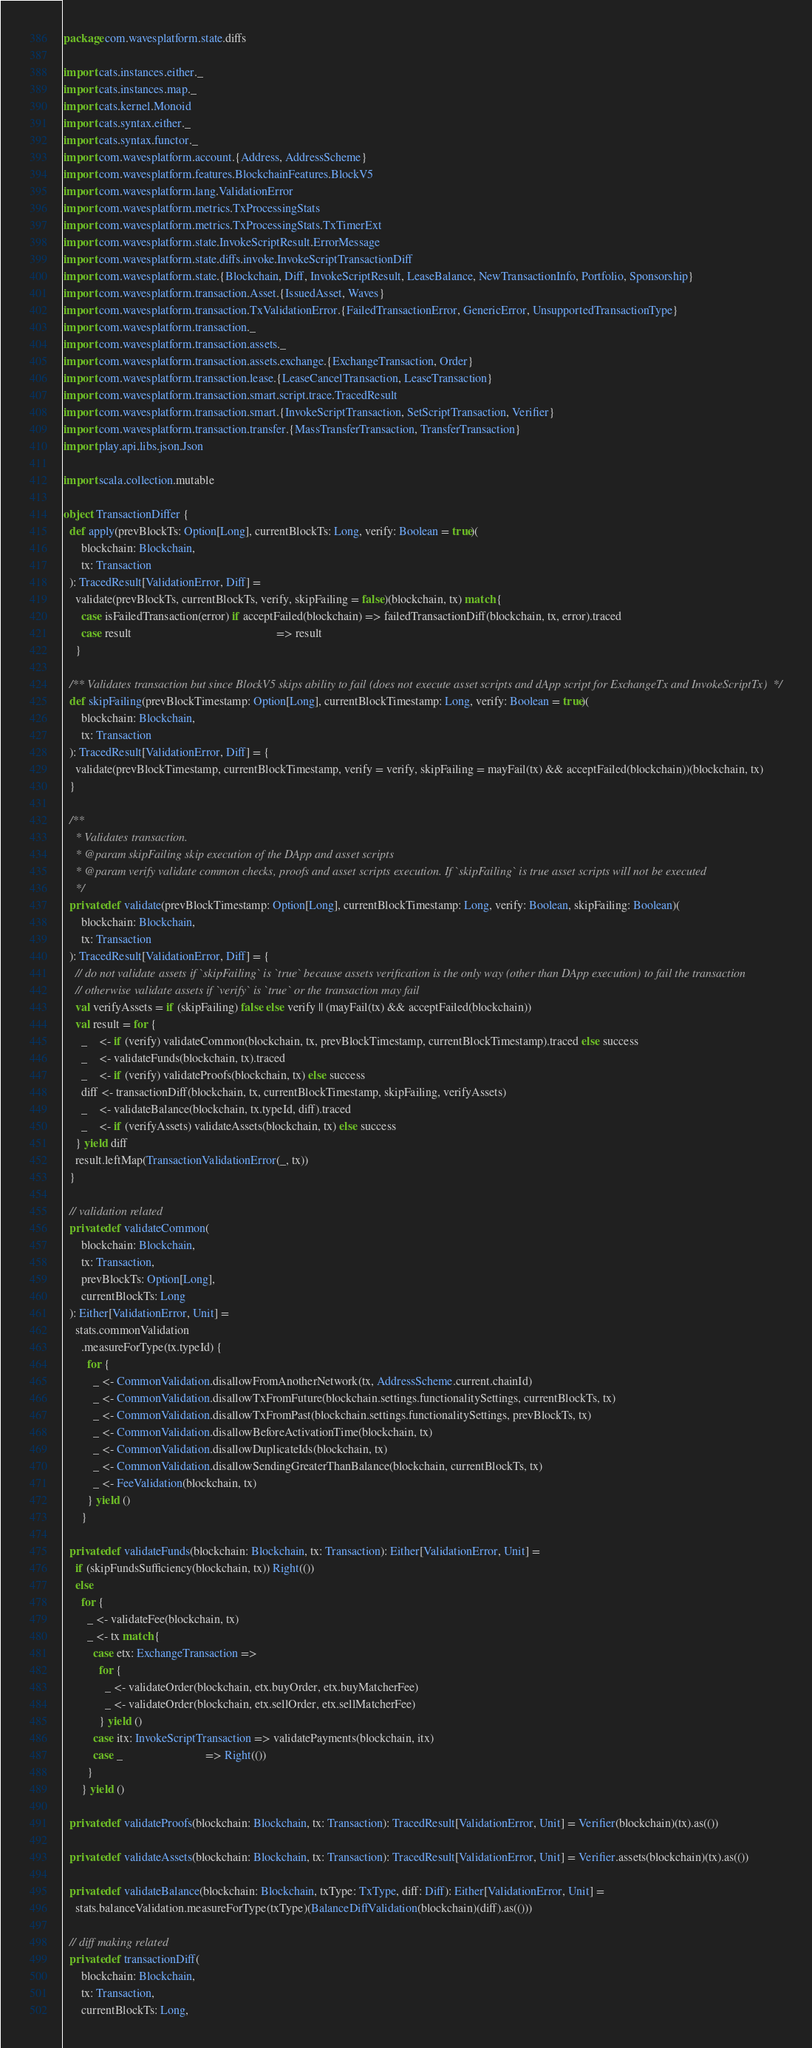<code> <loc_0><loc_0><loc_500><loc_500><_Scala_>package com.wavesplatform.state.diffs

import cats.instances.either._
import cats.instances.map._
import cats.kernel.Monoid
import cats.syntax.either._
import cats.syntax.functor._
import com.wavesplatform.account.{Address, AddressScheme}
import com.wavesplatform.features.BlockchainFeatures.BlockV5
import com.wavesplatform.lang.ValidationError
import com.wavesplatform.metrics.TxProcessingStats
import com.wavesplatform.metrics.TxProcessingStats.TxTimerExt
import com.wavesplatform.state.InvokeScriptResult.ErrorMessage
import com.wavesplatform.state.diffs.invoke.InvokeScriptTransactionDiff
import com.wavesplatform.state.{Blockchain, Diff, InvokeScriptResult, LeaseBalance, NewTransactionInfo, Portfolio, Sponsorship}
import com.wavesplatform.transaction.Asset.{IssuedAsset, Waves}
import com.wavesplatform.transaction.TxValidationError.{FailedTransactionError, GenericError, UnsupportedTransactionType}
import com.wavesplatform.transaction._
import com.wavesplatform.transaction.assets._
import com.wavesplatform.transaction.assets.exchange.{ExchangeTransaction, Order}
import com.wavesplatform.transaction.lease.{LeaseCancelTransaction, LeaseTransaction}
import com.wavesplatform.transaction.smart.script.trace.TracedResult
import com.wavesplatform.transaction.smart.{InvokeScriptTransaction, SetScriptTransaction, Verifier}
import com.wavesplatform.transaction.transfer.{MassTransferTransaction, TransferTransaction}
import play.api.libs.json.Json

import scala.collection.mutable

object TransactionDiffer {
  def apply(prevBlockTs: Option[Long], currentBlockTs: Long, verify: Boolean = true)(
      blockchain: Blockchain,
      tx: Transaction
  ): TracedResult[ValidationError, Diff] =
    validate(prevBlockTs, currentBlockTs, verify, skipFailing = false)(blockchain, tx) match {
      case isFailedTransaction(error) if acceptFailed(blockchain) => failedTransactionDiff(blockchain, tx, error).traced
      case result                                                 => result
    }

  /** Validates transaction but since BlockV5 skips ability to fail (does not execute asset scripts and dApp script for ExchangeTx and InvokeScriptTx) */
  def skipFailing(prevBlockTimestamp: Option[Long], currentBlockTimestamp: Long, verify: Boolean = true)(
      blockchain: Blockchain,
      tx: Transaction
  ): TracedResult[ValidationError, Diff] = {
    validate(prevBlockTimestamp, currentBlockTimestamp, verify = verify, skipFailing = mayFail(tx) && acceptFailed(blockchain))(blockchain, tx)
  }

  /**
    * Validates transaction.
    * @param skipFailing skip execution of the DApp and asset scripts
    * @param verify validate common checks, proofs and asset scripts execution. If `skipFailing` is true asset scripts will not be executed
    */
  private def validate(prevBlockTimestamp: Option[Long], currentBlockTimestamp: Long, verify: Boolean, skipFailing: Boolean)(
      blockchain: Blockchain,
      tx: Transaction
  ): TracedResult[ValidationError, Diff] = {
    // do not validate assets if `skipFailing` is `true` because assets verification is the only way (other than DApp execution) to fail the transaction
    // otherwise validate assets if `verify` is `true` or the transaction may fail
    val verifyAssets = if (skipFailing) false else verify || (mayFail(tx) && acceptFailed(blockchain))
    val result = for {
      _    <- if (verify) validateCommon(blockchain, tx, prevBlockTimestamp, currentBlockTimestamp).traced else success
      _    <- validateFunds(blockchain, tx).traced
      _    <- if (verify) validateProofs(blockchain, tx) else success
      diff <- transactionDiff(blockchain, tx, currentBlockTimestamp, skipFailing, verifyAssets)
      _    <- validateBalance(blockchain, tx.typeId, diff).traced
      _    <- if (verifyAssets) validateAssets(blockchain, tx) else success
    } yield diff
    result.leftMap(TransactionValidationError(_, tx))
  }

  // validation related
  private def validateCommon(
      blockchain: Blockchain,
      tx: Transaction,
      prevBlockTs: Option[Long],
      currentBlockTs: Long
  ): Either[ValidationError, Unit] =
    stats.commonValidation
      .measureForType(tx.typeId) {
        for {
          _ <- CommonValidation.disallowFromAnotherNetwork(tx, AddressScheme.current.chainId)
          _ <- CommonValidation.disallowTxFromFuture(blockchain.settings.functionalitySettings, currentBlockTs, tx)
          _ <- CommonValidation.disallowTxFromPast(blockchain.settings.functionalitySettings, prevBlockTs, tx)
          _ <- CommonValidation.disallowBeforeActivationTime(blockchain, tx)
          _ <- CommonValidation.disallowDuplicateIds(blockchain, tx)
          _ <- CommonValidation.disallowSendingGreaterThanBalance(blockchain, currentBlockTs, tx)
          _ <- FeeValidation(blockchain, tx)
        } yield ()
      }

  private def validateFunds(blockchain: Blockchain, tx: Transaction): Either[ValidationError, Unit] =
    if (skipFundsSufficiency(blockchain, tx)) Right(())
    else
      for {
        _ <- validateFee(blockchain, tx)
        _ <- tx match {
          case etx: ExchangeTransaction =>
            for {
              _ <- validateOrder(blockchain, etx.buyOrder, etx.buyMatcherFee)
              _ <- validateOrder(blockchain, etx.sellOrder, etx.sellMatcherFee)
            } yield ()
          case itx: InvokeScriptTransaction => validatePayments(blockchain, itx)
          case _                            => Right(())
        }
      } yield ()

  private def validateProofs(blockchain: Blockchain, tx: Transaction): TracedResult[ValidationError, Unit] = Verifier(blockchain)(tx).as(())

  private def validateAssets(blockchain: Blockchain, tx: Transaction): TracedResult[ValidationError, Unit] = Verifier.assets(blockchain)(tx).as(())

  private def validateBalance(blockchain: Blockchain, txType: TxType, diff: Diff): Either[ValidationError, Unit] =
    stats.balanceValidation.measureForType(txType)(BalanceDiffValidation(blockchain)(diff).as(()))

  // diff making related
  private def transactionDiff(
      blockchain: Blockchain,
      tx: Transaction,
      currentBlockTs: Long,</code> 